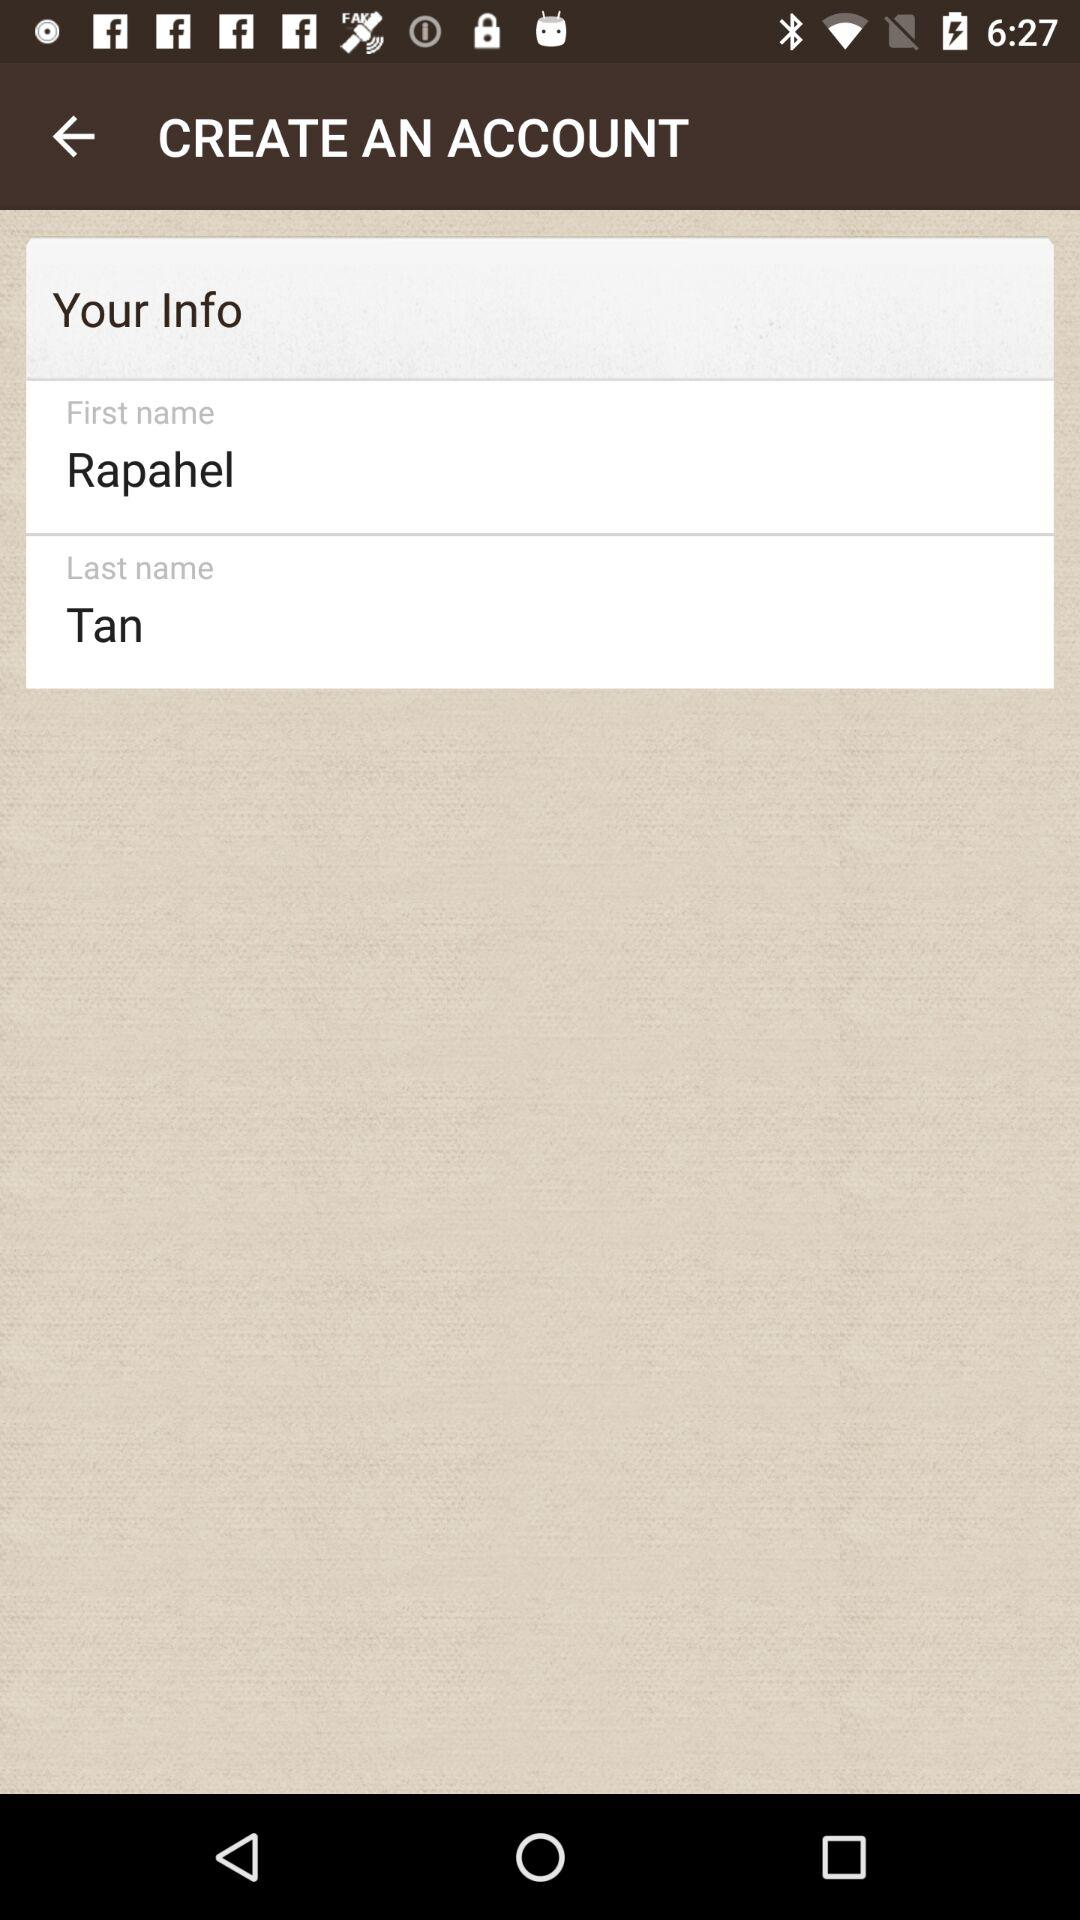How many input fields have been completed?
Answer the question using a single word or phrase. 2 